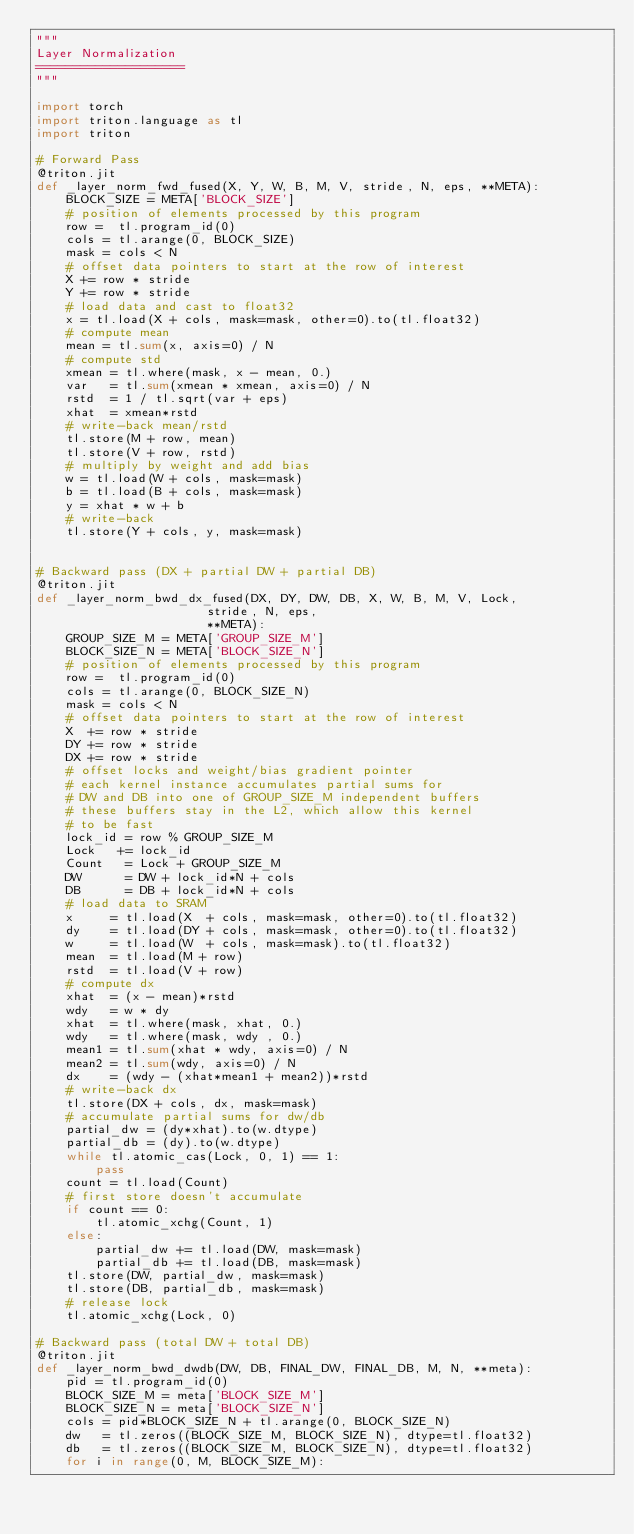<code> <loc_0><loc_0><loc_500><loc_500><_Python_>"""
Layer Normalization
====================
"""

import torch
import triton.language as tl
import triton

# Forward Pass
@triton.jit
def _layer_norm_fwd_fused(X, Y, W, B, M, V, stride, N, eps, **META):
    BLOCK_SIZE = META['BLOCK_SIZE']
    # position of elements processed by this program
    row =  tl.program_id(0)
    cols = tl.arange(0, BLOCK_SIZE)
    mask = cols < N
    # offset data pointers to start at the row of interest
    X += row * stride
    Y += row * stride
    # load data and cast to float32
    x = tl.load(X + cols, mask=mask, other=0).to(tl.float32)
    # compute mean
    mean = tl.sum(x, axis=0) / N
    # compute std
    xmean = tl.where(mask, x - mean, 0.)
    var   = tl.sum(xmean * xmean, axis=0) / N
    rstd  = 1 / tl.sqrt(var + eps)
    xhat  = xmean*rstd
    # write-back mean/rstd
    tl.store(M + row, mean)
    tl.store(V + row, rstd)
    # multiply by weight and add bias
    w = tl.load(W + cols, mask=mask)
    b = tl.load(B + cols, mask=mask)
    y = xhat * w + b
    # write-back
    tl.store(Y + cols, y, mask=mask)


# Backward pass (DX + partial DW + partial DB)
@triton.jit
def _layer_norm_bwd_dx_fused(DX, DY, DW, DB, X, W, B, M, V, Lock,
                       stride, N, eps, 
                       **META):
    GROUP_SIZE_M = META['GROUP_SIZE_M']
    BLOCK_SIZE_N = META['BLOCK_SIZE_N']
    # position of elements processed by this program
    row =  tl.program_id(0)
    cols = tl.arange(0, BLOCK_SIZE_N)
    mask = cols < N
    # offset data pointers to start at the row of interest
    X  += row * stride
    DY += row * stride
    DX += row * stride
    # offset locks and weight/bias gradient pointer
    # each kernel instance accumulates partial sums for
    # DW and DB into one of GROUP_SIZE_M independent buffers
    # these buffers stay in the L2, which allow this kernel
    # to be fast
    lock_id = row % GROUP_SIZE_M
    Lock   += lock_id
    Count   = Lock + GROUP_SIZE_M
    DW      = DW + lock_id*N + cols
    DB      = DB + lock_id*N + cols
    # load data to SRAM
    x     = tl.load(X  + cols, mask=mask, other=0).to(tl.float32)
    dy    = tl.load(DY + cols, mask=mask, other=0).to(tl.float32)
    w     = tl.load(W  + cols, mask=mask).to(tl.float32)
    mean  = tl.load(M + row)
    rstd  = tl.load(V + row)
    # compute dx
    xhat  = (x - mean)*rstd
    wdy   = w * dy
    xhat  = tl.where(mask, xhat, 0.)
    wdy   = tl.where(mask, wdy , 0.)
    mean1 = tl.sum(xhat * wdy, axis=0) / N
    mean2 = tl.sum(wdy, axis=0) / N
    dx    = (wdy - (xhat*mean1 + mean2))*rstd
    # write-back dx
    tl.store(DX + cols, dx, mask=mask)
    # accumulate partial sums for dw/db
    partial_dw = (dy*xhat).to(w.dtype)
    partial_db = (dy).to(w.dtype)
    while tl.atomic_cas(Lock, 0, 1) == 1:
        pass
    count = tl.load(Count)
    # first store doesn't accumulate
    if count == 0:
        tl.atomic_xchg(Count, 1)
    else:
        partial_dw += tl.load(DW, mask=mask)
        partial_db += tl.load(DB, mask=mask)
    tl.store(DW, partial_dw, mask=mask)
    tl.store(DB, partial_db, mask=mask)
    # release lock
    tl.atomic_xchg(Lock, 0)

# Backward pass (total DW + total DB)
@triton.jit
def _layer_norm_bwd_dwdb(DW, DB, FINAL_DW, FINAL_DB, M, N, **meta):
    pid = tl.program_id(0)
    BLOCK_SIZE_M = meta['BLOCK_SIZE_M']
    BLOCK_SIZE_N = meta['BLOCK_SIZE_N']
    cols = pid*BLOCK_SIZE_N + tl.arange(0, BLOCK_SIZE_N)
    dw   = tl.zeros((BLOCK_SIZE_M, BLOCK_SIZE_N), dtype=tl.float32)
    db   = tl.zeros((BLOCK_SIZE_M, BLOCK_SIZE_N), dtype=tl.float32)
    for i in range(0, M, BLOCK_SIZE_M):</code> 